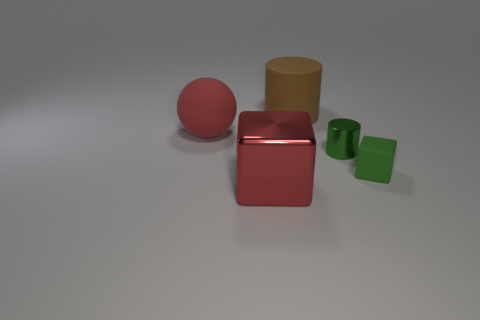Add 2 green cylinders. How many objects exist? 7 Subtract all green blocks. How many blocks are left? 1 Subtract all cubes. How many objects are left? 3 Subtract 0 yellow spheres. How many objects are left? 5 Subtract 1 balls. How many balls are left? 0 Subtract all purple spheres. Subtract all brown cylinders. How many spheres are left? 1 Subtract all blue balls. How many green cylinders are left? 1 Subtract all large brown objects. Subtract all large objects. How many objects are left? 1 Add 2 large rubber cylinders. How many large rubber cylinders are left? 3 Add 2 green matte cubes. How many green matte cubes exist? 3 